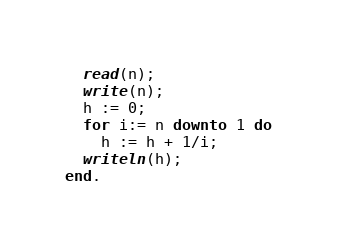<code> <loc_0><loc_0><loc_500><loc_500><_Pascal_>  read(n);
  write(n);
  h := 0;
  for i:= n downto 1 do
    h := h + 1/i;
  writeln(h);
end.</code> 